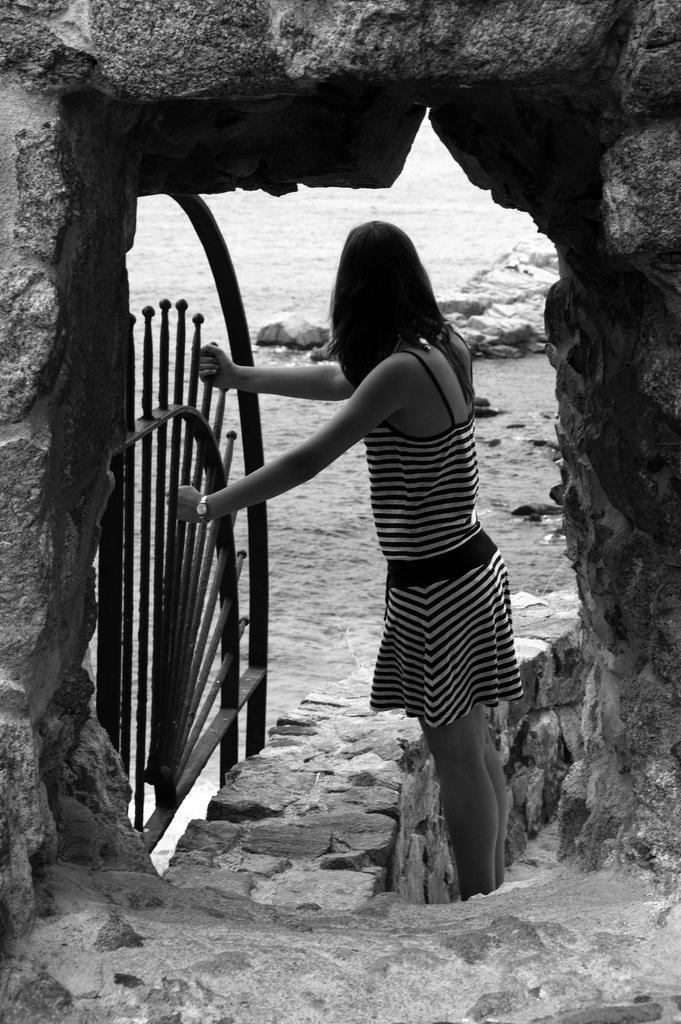Could you give a brief overview of what you see in this image? This is a black and white picture. Here we can see a woman holding an object. Here we can see wall, arch, water, and rocks. 